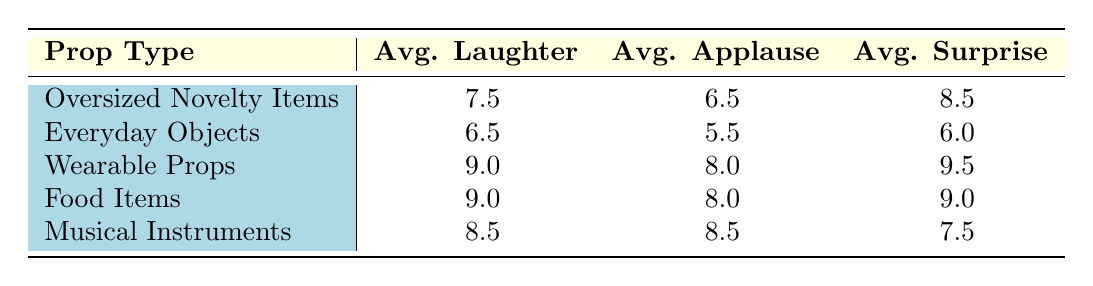What is the average laughter intensity for Wearable Props? The laughter intensity for Wearable Props is listed as 9. Using the table, we can see this value directly under the Average Laughter column for that prop type.
Answer: 9 Which prop type has the highest applause level? The highest applause level in the table is 9, which is shared by both Wearable Props and Food Items. By comparing the values in the Average Applause column, we can see these are the only categories that reach this figure.
Answer: Wearable Props and Food Items What is the average surprise rating across all prop types? To find the average surprise rating, we add the surprise ratings (8.5 + 6.0 + 9.5 + 9.0 + 7.5) = 40.5 and then divide by the number of prop types, which is 5, resulting in 40.5/5 = 8.1.
Answer: 8.1 Is the average laughter intensity for Food Items greater than that of Everyday Objects? The average laughter intensity for Food Items is 9.0, while for Everyday Objects, it is 6.5. Since 9.0 is greater than 6.5, the statement is true.
Answer: Yes Which prop type shows the least surprise rating on average? To determine which prop type has the least surprise rating, we look at the Average Surprise column. Everyday Objects has a rating of 6.0, the lowest among all the categories, confirming it as the least surprising prop type.
Answer: Everyday Objects What is the difference in average applause levels between Oversized Novelty Items and Musical Instruments? The average applause level for Oversized Novelty Items is 6.5, while for Musical Instruments, it is 8.5. The difference is found by subtracting: 8.5 - 6.5 = 2.0.
Answer: 2.0 How many prop types have an average surprise rating of 9 or higher? By examining the Average Surprise ratings, both Wearable Props and Food Items have a rating of 9 or higher. Adding them, that gives us 2 prop types out of 5.
Answer: 2 What is the average applause level for all prop types combined? To find the average applause level, we sum the applause levels (6.5 + 5.5 + 8.0 + 8.0 + 8.5) = 36.5 and divide by the number of prop types (5), giving us 36.5/5 = 7.3.
Answer: 7.3 